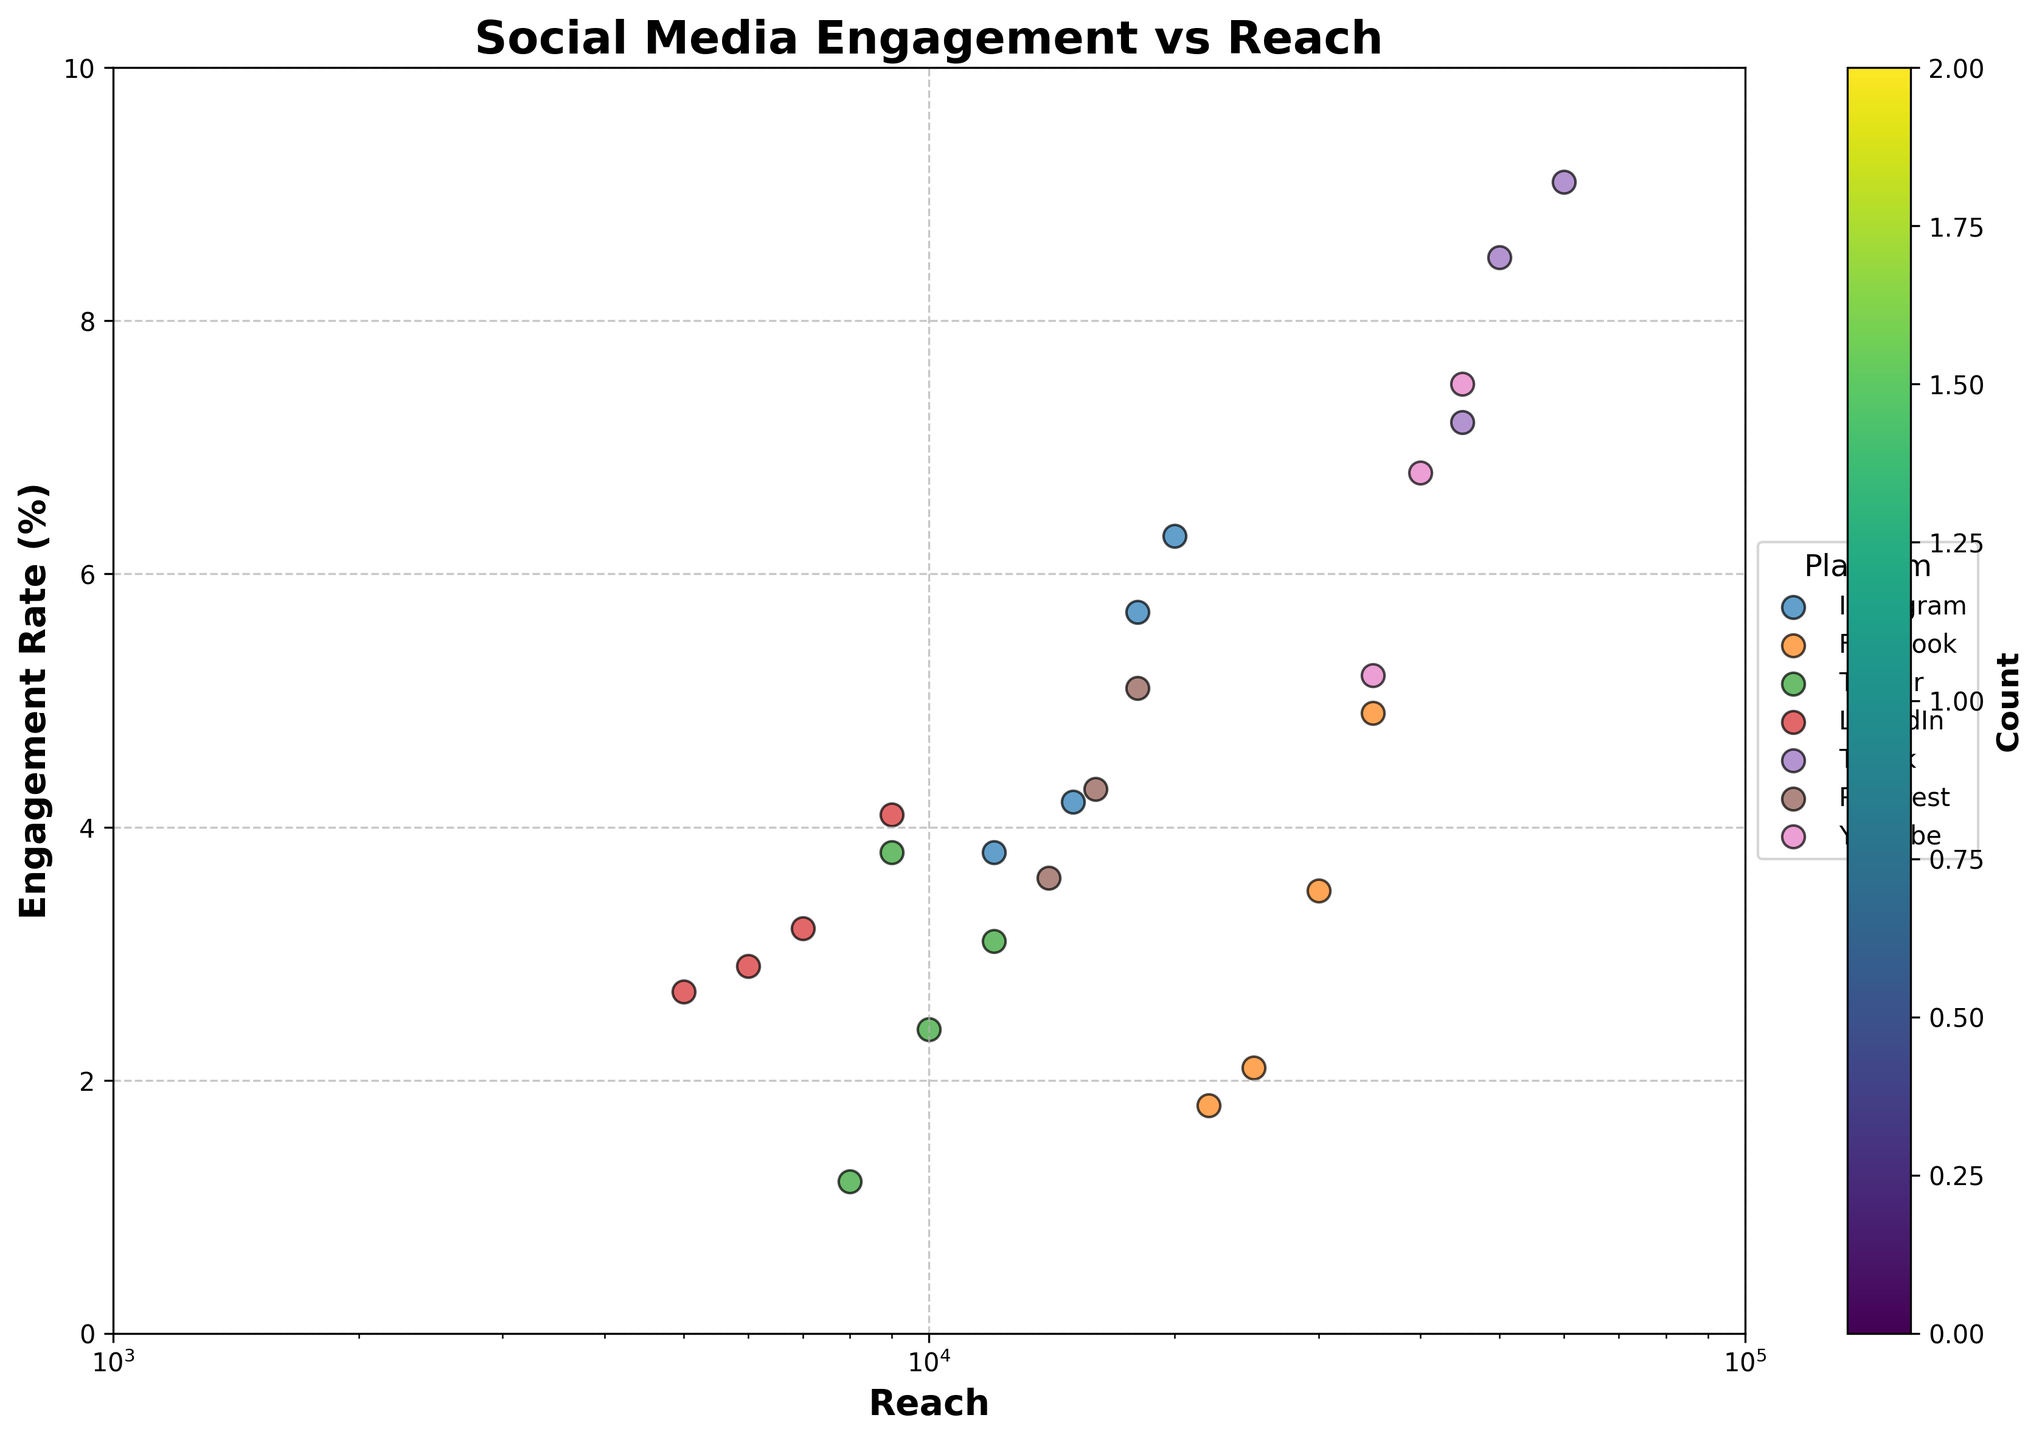What is the title of the plot? The title of the plot is often the largest text at the top center of the figure, summarizing the main topic being illustrated. In this case, it is seen as "Social Media Engagement vs Reach."
Answer: Social Media Engagement vs Reach What colors are used for the hexagons in the plot? The colors utilized for the hexagons indicate count density, and they are various shades from the "viridis" color palette, ranging from light green to dark blue.
Answer: Shades of green and blue How are platforms represented on the plot? Platforms are represented using different marker symbols and colors over the hexbin plot. The legend on the right side of the plot identifies each symbol with its respective platform.
Answer: By different marker symbols and colors What are the axis labels for the plot? The x-axis label is "Reach," which is shown at the bottom of the plot, while the y-axis label is "Engagement Rate (%)" positioned vertically along the left side of the plot.
Answer: Reach (x-axis) and Engagement Rate (%) (y-axis) Which platform appears to have the highest engagement rate for any content type? By observing the plot, one can identify the platform with a marker at the highest position on the y-axis (Engagement Rate) among the data points. Analyzing this, TikTok appears to have the highest engagement rate.
Answer: TikTok What is the range of the x-axis (Reach)? The plot's x-axis range is visually inspected by looking at the minimum and maximum values shown. The range starts from 1,000 and extends up to 100,000.
Answer: 1,000 to 100,000 Which platform shows the widest range of engagement rates? By comparing the vertical spread of markers for each platform, Instagram demonstrates the widest variability in engagement rates, extending from approximately 1% to over 6%.
Answer: Instagram What does the color intensity on the hexbin plot indicate? The color intensity on a hexbin plot correlates with the count of data points within that hexagon. A darker or stronger color shows a higher density of data points.
Answer: Count density How does the engagement rate of Instagram's Carousel compare to Facebook's Video content? By checking the labeled markers for Instagram's Carousel and Facebook's Video, Instagram's Carousel has a higher engagement rate than Facebook's Video.
Answer: Instagram's Carousel is higher How many platforms have an engagement rate greater than 5%? By examining the plot and counting platforms that have markers above the 5% mark on the y-axis, three platforms (TikTok, Instagram, and YouTube) exhibit engagement rates greater than 5%.
Answer: Three platforms 